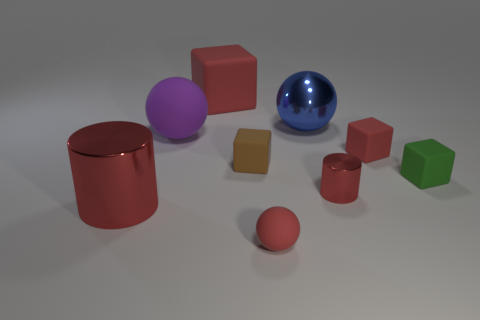There is a ball that is in front of the small green rubber block; is its color the same as the rubber thing that is behind the metallic ball?
Your answer should be very brief. Yes. There is a brown thing; are there any purple spheres in front of it?
Offer a terse response. No. There is a thing that is both in front of the green block and on the left side of the small brown rubber object; what is its color?
Your response must be concise. Red. Are there any tiny rubber balls of the same color as the big cylinder?
Your answer should be compact. Yes. Does the big red thing that is behind the tiny green thing have the same material as the cylinder on the right side of the big blue metal ball?
Your answer should be very brief. No. There is a matte ball that is to the right of the big matte ball; what size is it?
Your answer should be compact. Small. The red sphere is what size?
Ensure brevity in your answer.  Small. What size is the red metallic thing that is to the right of the small matte thing that is on the left side of the small red matte object that is in front of the large red metal cylinder?
Keep it short and to the point. Small. Is there a large blue thing made of the same material as the blue ball?
Provide a short and direct response. No. What is the shape of the green thing?
Offer a terse response. Cube. 